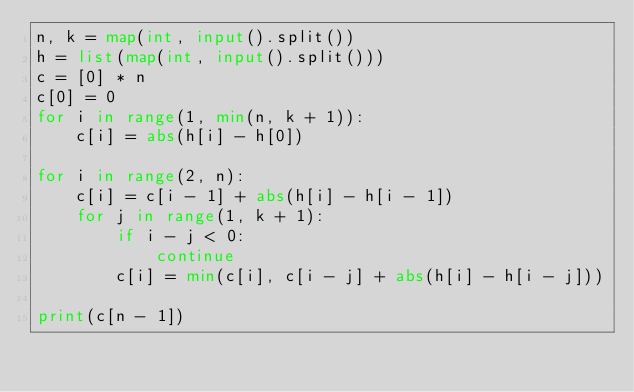<code> <loc_0><loc_0><loc_500><loc_500><_Python_>n, k = map(int, input().split())
h = list(map(int, input().split()))
c = [0] * n
c[0] = 0
for i in range(1, min(n, k + 1)):
    c[i] = abs(h[i] - h[0])

for i in range(2, n):
    c[i] = c[i - 1] + abs(h[i] - h[i - 1])
    for j in range(1, k + 1):
        if i - j < 0:
            continue
        c[i] = min(c[i], c[i - j] + abs(h[i] - h[i - j]))

print(c[n - 1])
</code> 